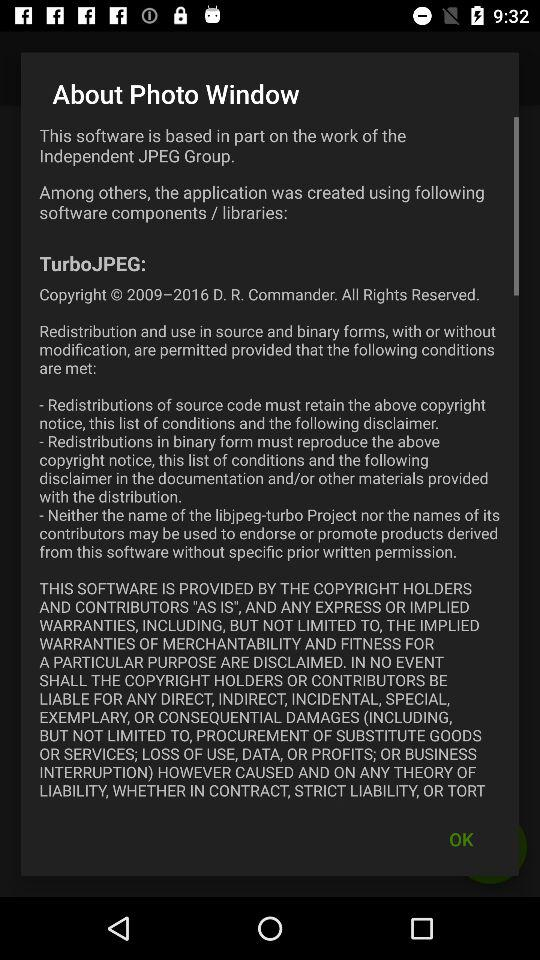What is the software name? The software name is "Photo Window". 